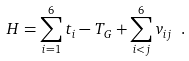Convert formula to latex. <formula><loc_0><loc_0><loc_500><loc_500>H = \sum ^ { 6 } _ { i = 1 } t _ { i } - T _ { G } + \sum ^ { 6 } _ { i < j } v _ { i j } \ .</formula> 